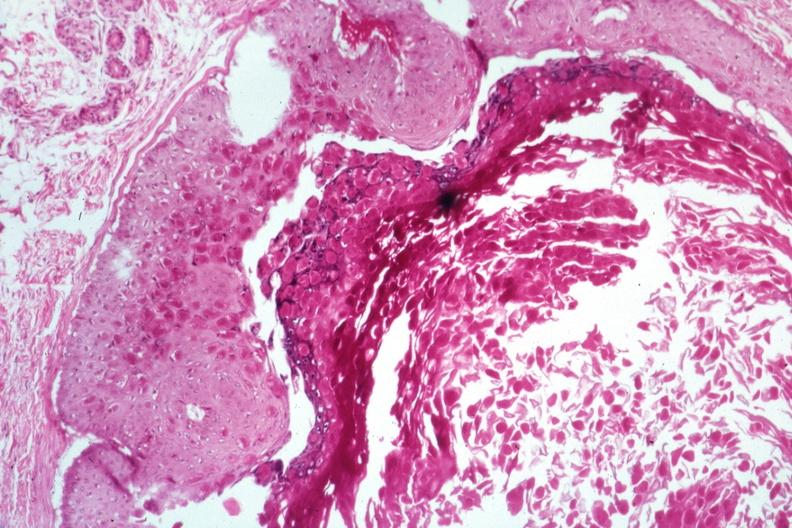where is this?
Answer the question using a single word or phrase. Skin 